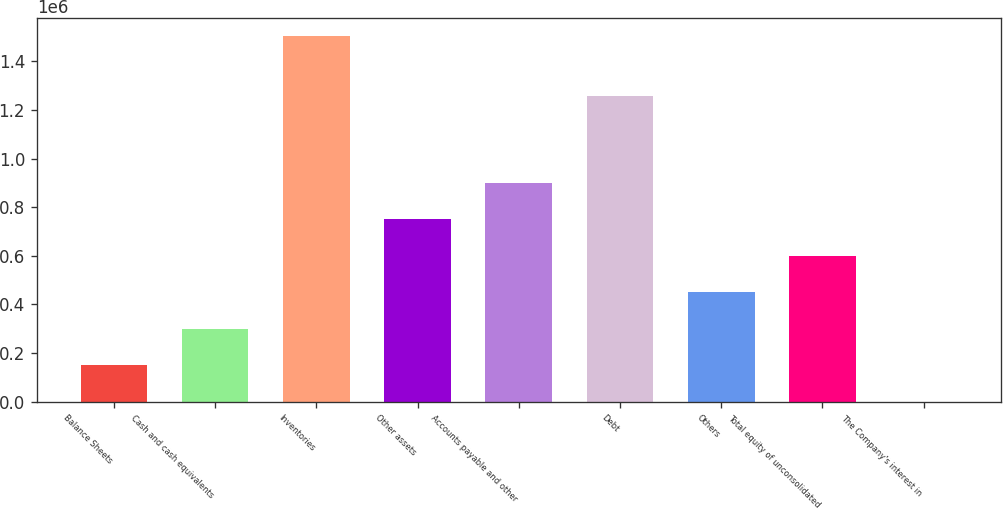Convert chart to OTSL. <chart><loc_0><loc_0><loc_500><loc_500><bar_chart><fcel>Balance Sheets<fcel>Cash and cash equivalents<fcel>Inventories<fcel>Other assets<fcel>Accounts payable and other<fcel>Debt<fcel>Others<fcel>Total equity of unconsolidated<fcel>The Company's interest in<nl><fcel>150240<fcel>300464<fcel>1.50225e+06<fcel>751135<fcel>901359<fcel>1.25578e+06<fcel>450687<fcel>600911<fcel>16<nl></chart> 